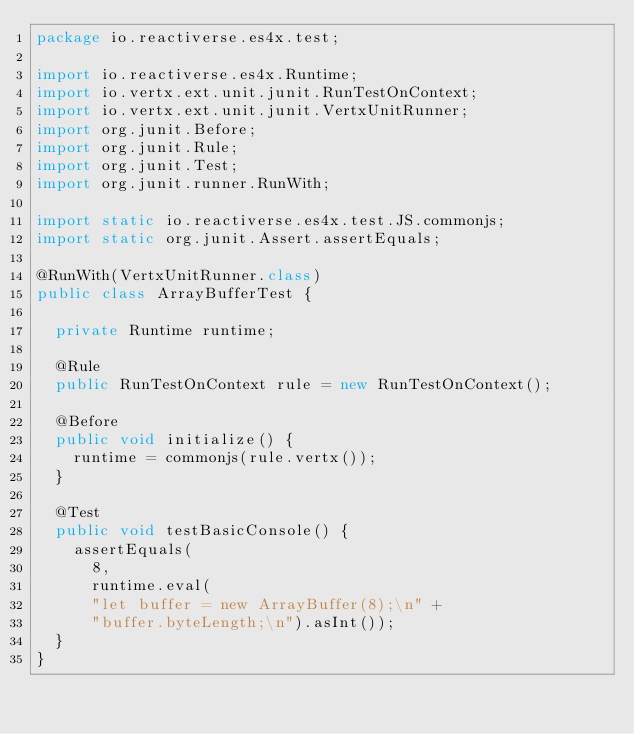Convert code to text. <code><loc_0><loc_0><loc_500><loc_500><_Java_>package io.reactiverse.es4x.test;

import io.reactiverse.es4x.Runtime;
import io.vertx.ext.unit.junit.RunTestOnContext;
import io.vertx.ext.unit.junit.VertxUnitRunner;
import org.junit.Before;
import org.junit.Rule;
import org.junit.Test;
import org.junit.runner.RunWith;

import static io.reactiverse.es4x.test.JS.commonjs;
import static org.junit.Assert.assertEquals;

@RunWith(VertxUnitRunner.class)
public class ArrayBufferTest {

  private Runtime runtime;

  @Rule
  public RunTestOnContext rule = new RunTestOnContext();

  @Before
  public void initialize() {
    runtime = commonjs(rule.vertx());
  }

  @Test
  public void testBasicConsole() {
    assertEquals(
      8,
      runtime.eval(
      "let buffer = new ArrayBuffer(8);\n" +
      "buffer.byteLength;\n").asInt());
  }
}
</code> 